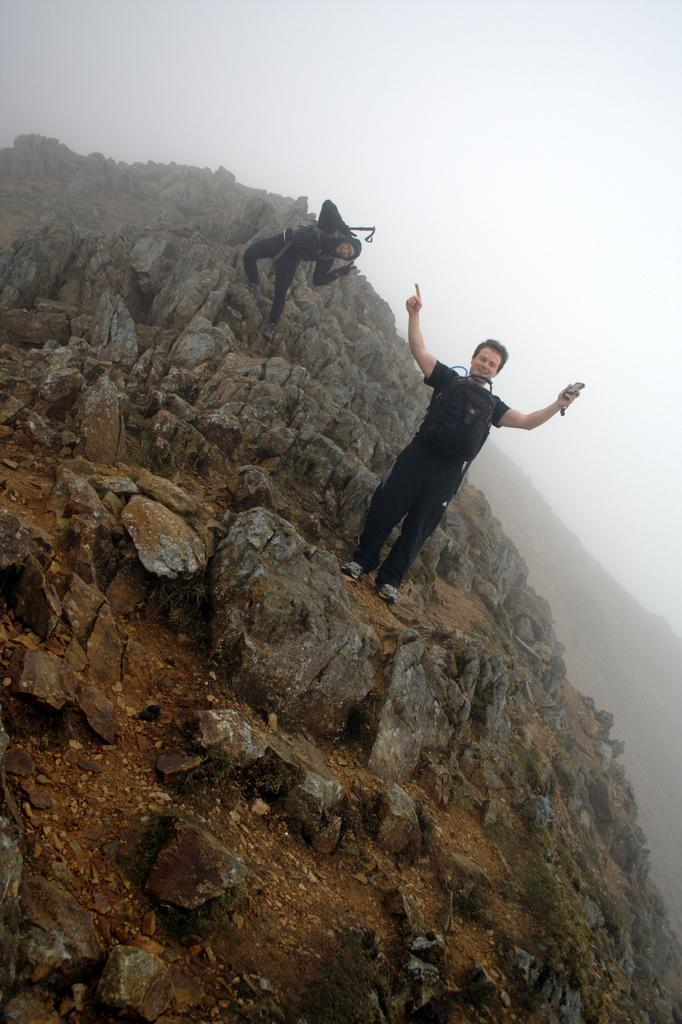How many people are in the image? There are two men in the image. What are the men wearing? The men are wearing black dresses. Where are the men standing? The men are standing on a hill. What is visible above the hill? The sky is visible above the hill. Can you tell me how many frogs are sitting on the button in the image? There are no frogs or buttons present in the image. What type of cast is visible on the arm of one of the men in the image? There is no cast visible on either of the men in the image. 